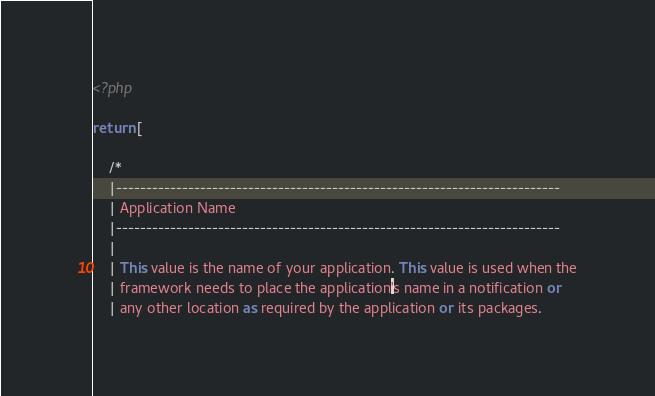<code> <loc_0><loc_0><loc_500><loc_500><_PHP_><?php

return [

    /*
    |--------------------------------------------------------------------------
    | Application Name
    |--------------------------------------------------------------------------
    |
    | This value is the name of your application. This value is used when the
    | framework needs to place the application's name in a notification or
    | any other location as required by the application or its packages.</code> 